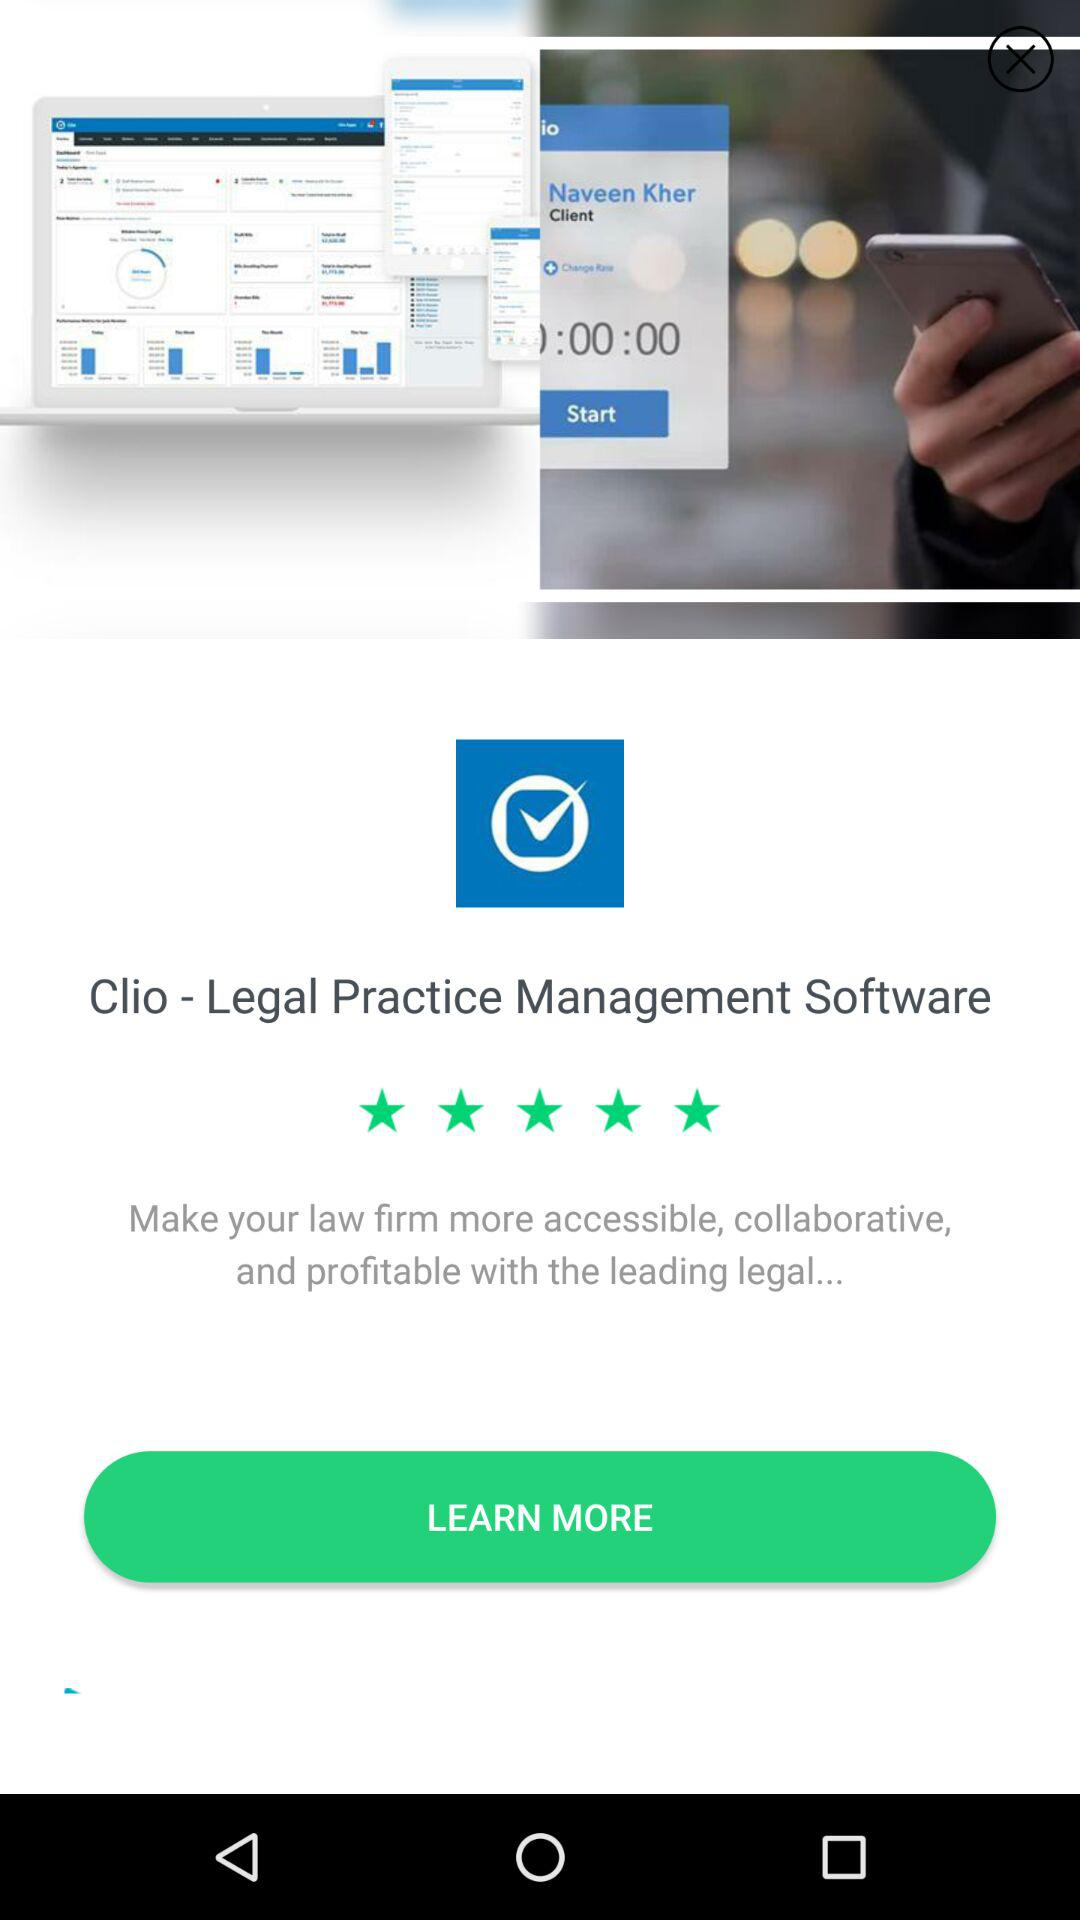How many people have rated this app?
When the provided information is insufficient, respond with <no answer>. <no answer> 